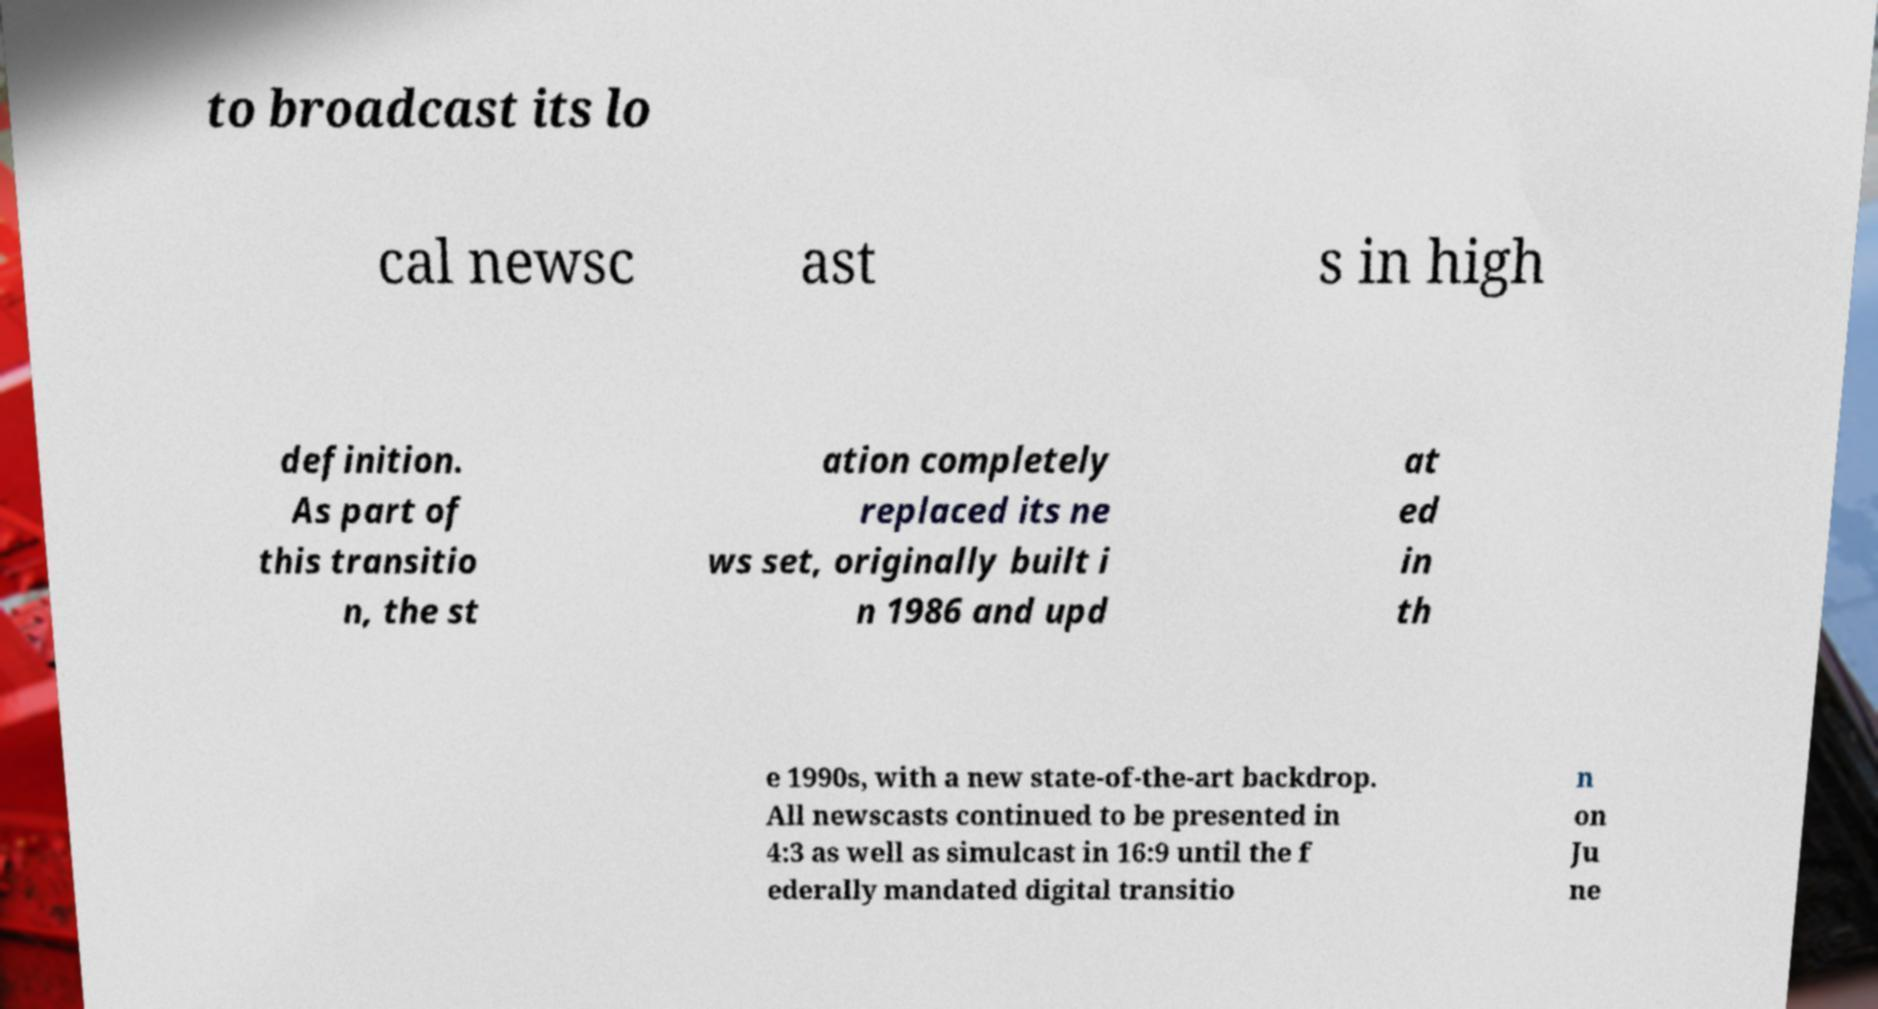Could you extract and type out the text from this image? to broadcast its lo cal newsc ast s in high definition. As part of this transitio n, the st ation completely replaced its ne ws set, originally built i n 1986 and upd at ed in th e 1990s, with a new state-of-the-art backdrop. All newscasts continued to be presented in 4:3 as well as simulcast in 16:9 until the f ederally mandated digital transitio n on Ju ne 